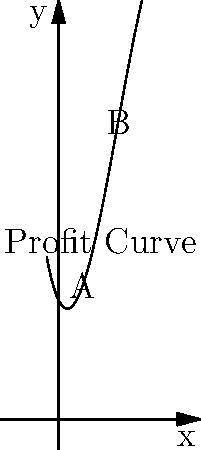As a local business owner in Winsted, Connecticut, you're analyzing your profit curve, which is represented by the polynomial function $f(x) = -0.1x^3 + 1.5x^2 - 2x + 10$, where $x$ represents the number of thousands of units sold and $f(x)$ represents the profit in hundreds of dollars. What is the difference in profit between points A and B on the curve? To solve this problem, we need to follow these steps:

1. Identify the x-coordinates of points A and B:
   Point A is at x = 2 (2,000 units)
   Point B is at x = 5 (5,000 units)

2. Calculate the profit at point A:
   $f(2) = -0.1(2)^3 + 1.5(2)^2 - 2(2) + 10$
   $= -0.8 + 6 - 4 + 10 = 11.2$

3. Calculate the profit at point B:
   $f(5) = -0.1(5)^3 + 1.5(5)^2 - 2(5) + 10$
   $= -12.5 + 37.5 - 10 + 10 = 25$

4. Calculate the difference in profit:
   Difference = $f(5) - f(2) = 25 - 11.2 = 13.8$

5. Convert the result to hundreds of dollars:
   13.8 hundred dollars = $1,380

Therefore, the difference in profit between points A and B is $1,380.
Answer: $1,380 